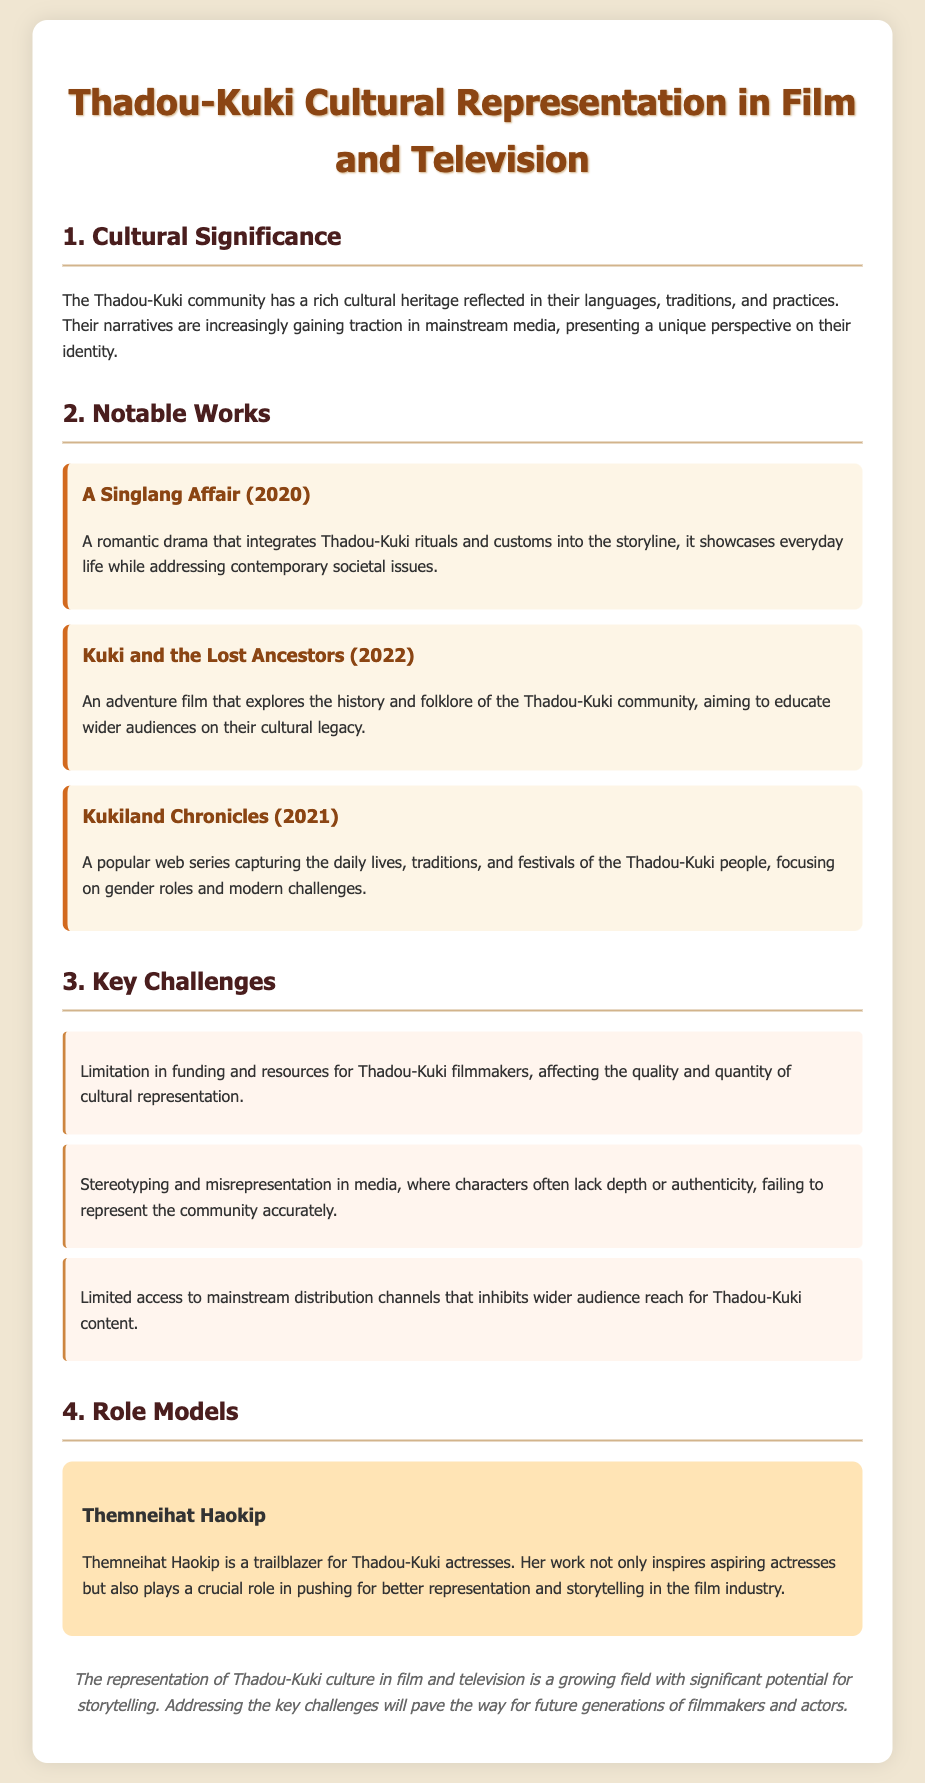What is the title of the document? The title of the document is at the top of the content above the sections listed.
Answer: Thadou-Kuki Cultural Representation in Film and Television What year was "A Singlang Affair" released? The release year of "A Singlang Affair" is specifically mentioned along with the work details.
Answer: 2020 Which film explores the folklore of the Thadou-Kuki community? The film that explores folklore is listed among notable works in the document.
Answer: Kuki and the Lost Ancestors What is a key challenge faced by Thadou-Kuki filmmakers? A specific challenge related to funding and resources is given, highlighting issues with representation.
Answer: Limitation in funding and resources Who is mentioned as a role model for Thadou-Kuki actresses? The name listed in the role model section as an influential figure is searched for in that context.
Answer: Themneihat Haokip How many notable works are listed in the document? The total number of listed works can be counted from the notable works section.
Answer: 3 What is a focus of the web series "Kukiland Chronicles"? The central theme of "Kukiland Chronicles" is addressed in the description allowing for concise retrieval.
Answer: Daily lives, traditions, and festivals What is the document's conclusion about Thadou-Kuki representation? The conclusion summarizes the potential and challenges mentioned throughout the document.
Answer: Growing field with significant potential for storytelling 